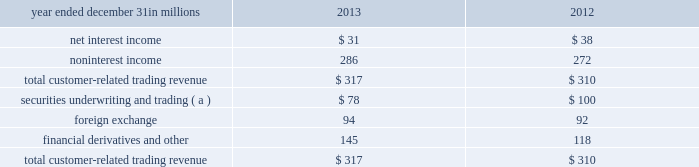Simulations assume that as assets and liabilities mature , they are replaced or repriced at then current market rates .
We also consider forward projections of purchase accounting accretion when forecasting net interest income .
The following graph presents the libor/swap yield curves for the base rate scenario and each of the alternate scenarios one year forward .
Table 52 : alternate interest rate scenarios : one year forward base rates pnc economist market forward slope flattening 2y 3y 5y 10y the fourth quarter 2013 interest sensitivity analyses indicate that our consolidated balance sheet is positioned to benefit from an increase in interest rates and an upward sloping interest rate yield curve .
We believe that we have the deposit funding base and balance sheet flexibility to adjust , where appropriate and permissible , to changing interest rates and market conditions .
Market risk management 2013 customer-related trading risk we engage in fixed income securities , derivatives and foreign exchange transactions to support our customers 2019 investing and hedging activities .
These transactions , related hedges and the credit valuation adjustment ( cva ) related to our customer derivatives portfolio are marked-to-market on a daily basis and reported as customer-related trading activities .
We do not engage in proprietary trading of these products .
We use value-at-risk ( var ) as the primary means to measure and monitor market risk in customer-related trading activities .
We calculate a diversified var at a 95% ( 95 % ) confidence interval .
Var is used to estimate the probability of portfolio losses based on the statistical analysis of historical market risk factors .
A diversified var reflects empirical correlations across different asset classes .
During 2013 , our 95% ( 95 % ) var ranged between $ 1.7 million and $ 5.5 million , averaging $ 3.5 million .
During 2012 , our 95% ( 95 % ) var ranged between $ 1.1 million and $ 5.3 million , averaging $ 3.2 million .
To help ensure the integrity of the models used to calculate var for each portfolio and enterprise-wide , we use a process known as backtesting .
The backtesting process consists of comparing actual observations of gains or losses against the var levels that were calculated at the close of the prior day .
This assumes that market exposures remain constant throughout the day and that recent historical market variability is a good predictor of future variability .
Our customer-related trading activity includes customer revenue and intraday hedging which helps to reduce losses , and may reduce the number of instances of actual losses exceeding the prior day var measure .
There was one such instance during 2013 under our diversified var measure where actual losses exceeded the prior day var measure .
In comparison , there were two such instances during 2012 .
We use a 500 day look back period for backtesting and include customer-related revenue .
The following graph shows a comparison of enterprise-wide gains and losses against prior day diversified var for the period indicated .
Table 53 : enterprise-wide gains/losses versus value-at- 12/31/12 1/31/13 2/28/13 3/31/13 4/30/13 5/31/13 6/30/13 7/31/13 8/31/13 9/30/13 10/31/13 11/30/13 12/31/13 total customer-related trading revenue was as follows : table 54 : customer-related trading revenue year ended december 31 in millions 2013 2012 .
( a ) includes changes in fair value for certain loans accounted for at fair value .
Customer-related trading revenues for 2013 increased $ 7 million compared with 2012 .
The increase primarily resulted from the impact of higher market interest rates on credit valuations for customer-related derivatives activities and improved debt underwriting results which were partially offset by reduced client sales revenue .
The pnc financial services group , inc .
2013 form 10-k 93 .
For 2013 and 2012 , what was total noninterest income in millions? 
Computations: (286 + 272)
Answer: 558.0. 